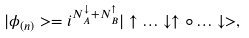<formula> <loc_0><loc_0><loc_500><loc_500>| \phi _ { ( n ) } > = i ^ { N _ { A } ^ { \downarrow } + N _ { B } ^ { \uparrow } } | \uparrow \dots \downarrow \uparrow \circ \dots \downarrow > ,</formula> 